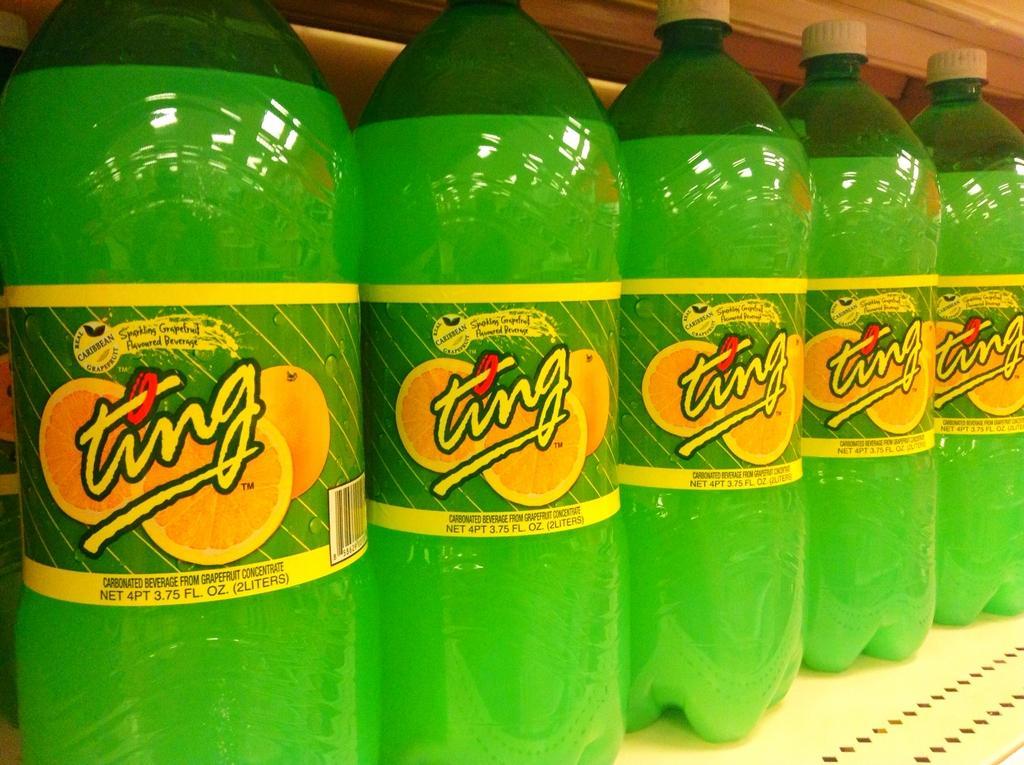How would you summarize this image in a sentence or two? Here we can see a five cool drink bottles which are kept in a sequence. 